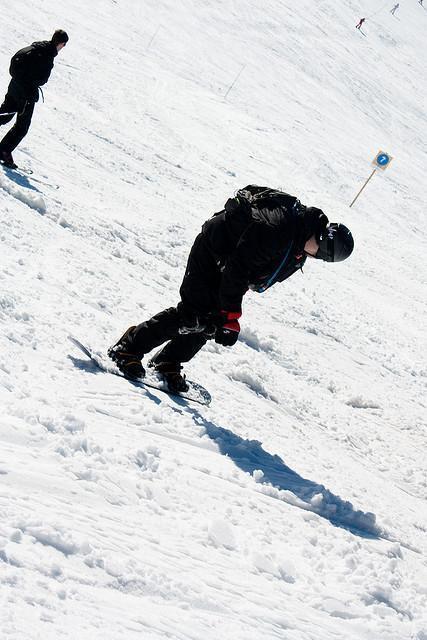How many people are there?
Give a very brief answer. 2. 